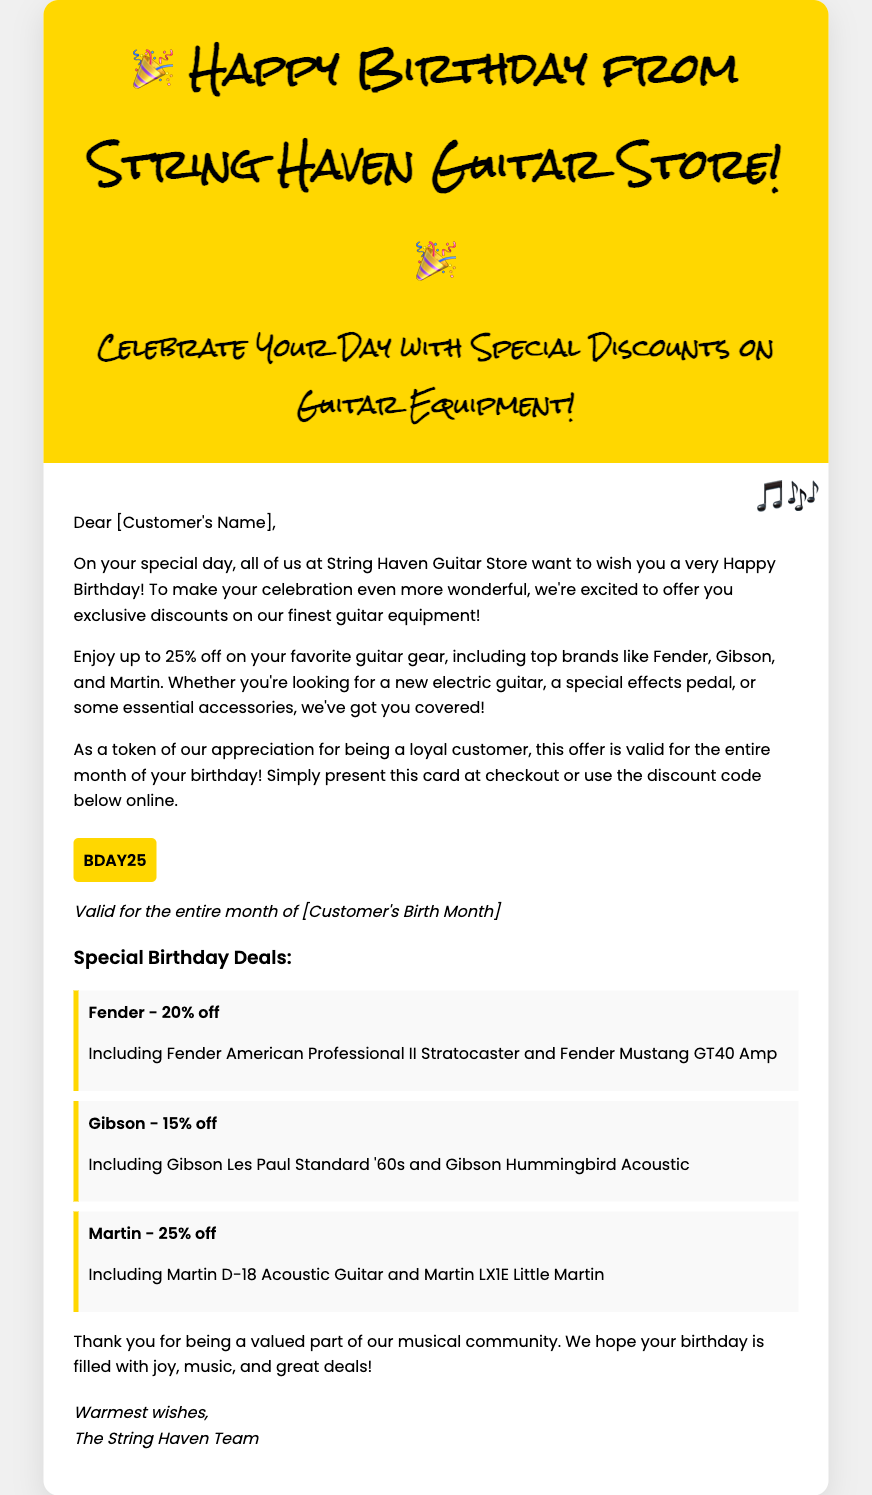What is the name of the store? The greeting card clearly states the name of the store in the header.
Answer: String Haven Guitar Store What is the discount code? The discount code is highlighted in the document for customers to use at checkout.
Answer: BDAY25 How much discount can customers enjoy on Martin guitars? The document specifies the discount percentage for Martin guitars in the special deals section.
Answer: 25% off What is the expiry duration of the offer? The offer's validity is explicitly mentioned for the month surrounding the customer's birthday.
Answer: Entire month of [Customer's Birth Month] Which brand has a 20% discount? Specific brands and their discount percentages are listed under the special deals section.
Answer: Fender What type of products are included in the offer? The document describes the types of products eligible for discounts in the main content.
Answer: Guitar equipment Who is the card addressed to? The greeting card begins with a personal address to the recipient.
Answer: [Customer's Name] What is the theme symbol used in the card? The document features a musical symbol prominently throughout the design.
Answer: Musical notes 